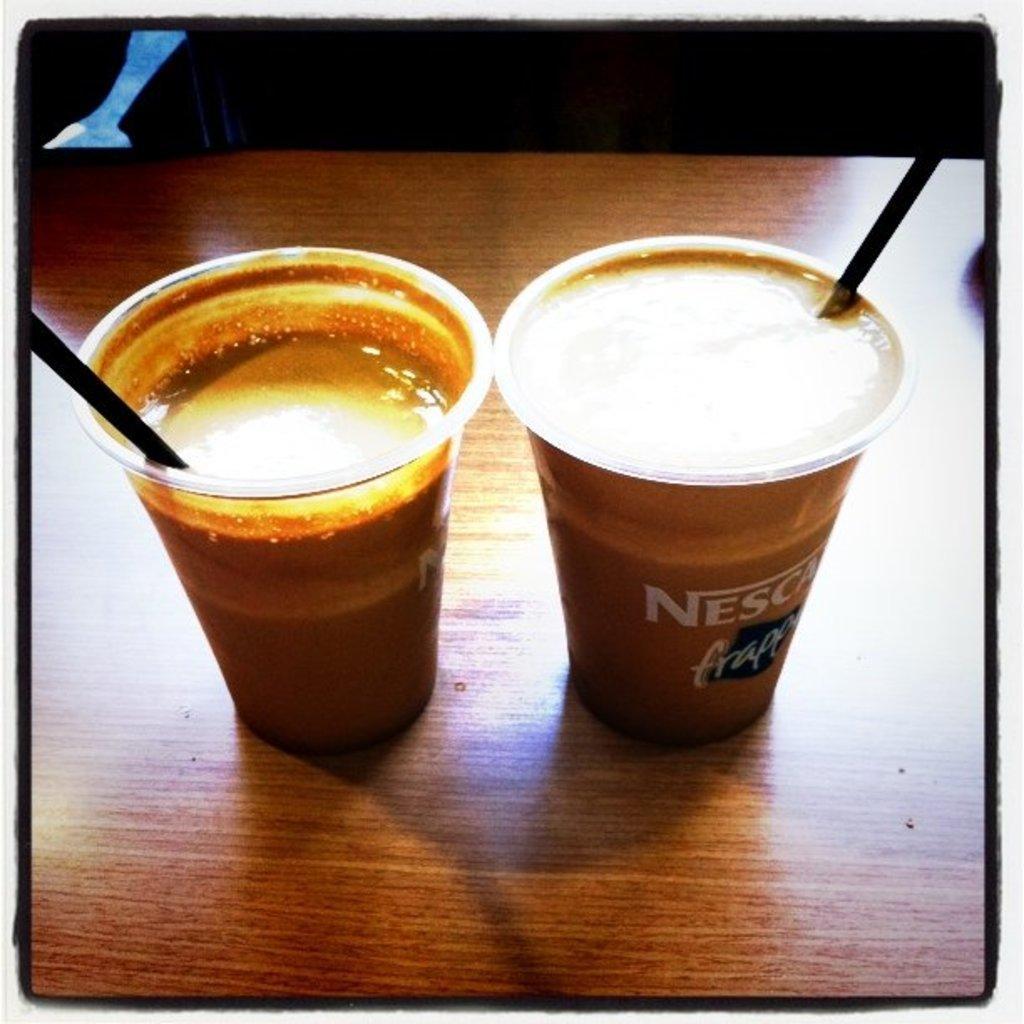How would you summarize this image in a sentence or two? This is an edited image with the borders. In the foreground we can see the two glasses of drinks seems to be the coffee, containing straws, the glasses are placed on the top of the table. 